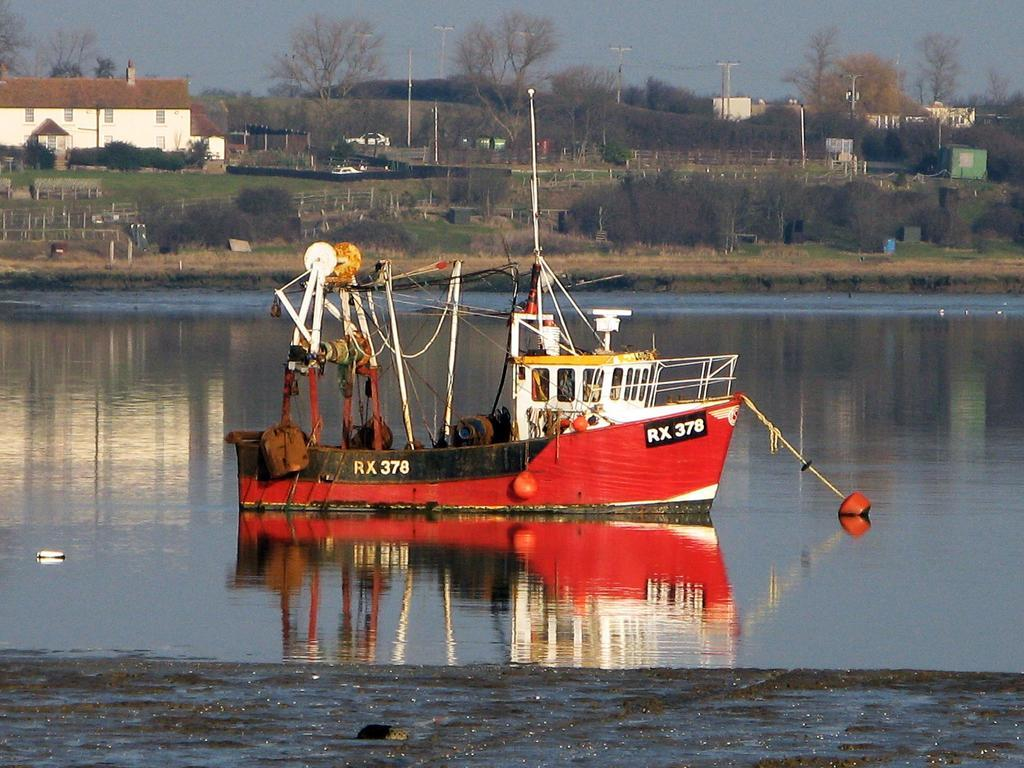What is the main subject of the image? The main subject of the image is a boat on the water. What type of natural environment can be seen in the image? Grass, trees, and the sky are visible in the image, indicating a natural environment. What man-made structures are present in the image? Houses and poles are present in the image. What else can be seen in the image besides the boat and natural environment? Vehicles and some unspecified objects are also visible in the image. What type of beast is sitting on the sofa in the image? There is no sofa or beast present in the image. 